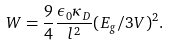Convert formula to latex. <formula><loc_0><loc_0><loc_500><loc_500>W = \frac { 9 } { 4 } \frac { \epsilon _ { 0 } \kappa _ { D } } { l ^ { 2 } } ( E _ { g } / 3 V ) ^ { 2 } .</formula> 